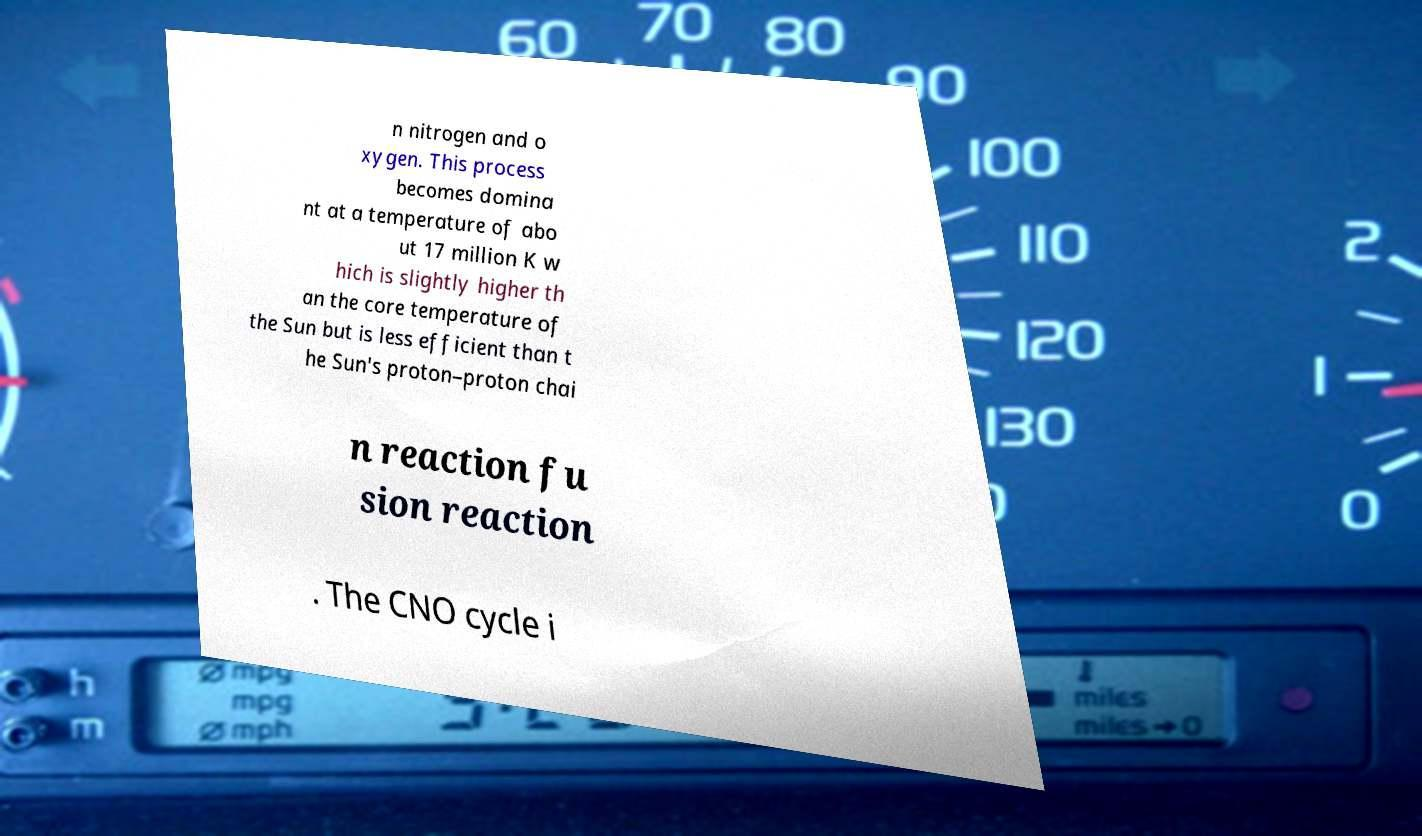I need the written content from this picture converted into text. Can you do that? n nitrogen and o xygen. This process becomes domina nt at a temperature of abo ut 17 million K w hich is slightly higher th an the core temperature of the Sun but is less efficient than t he Sun's proton–proton chai n reaction fu sion reaction . The CNO cycle i 